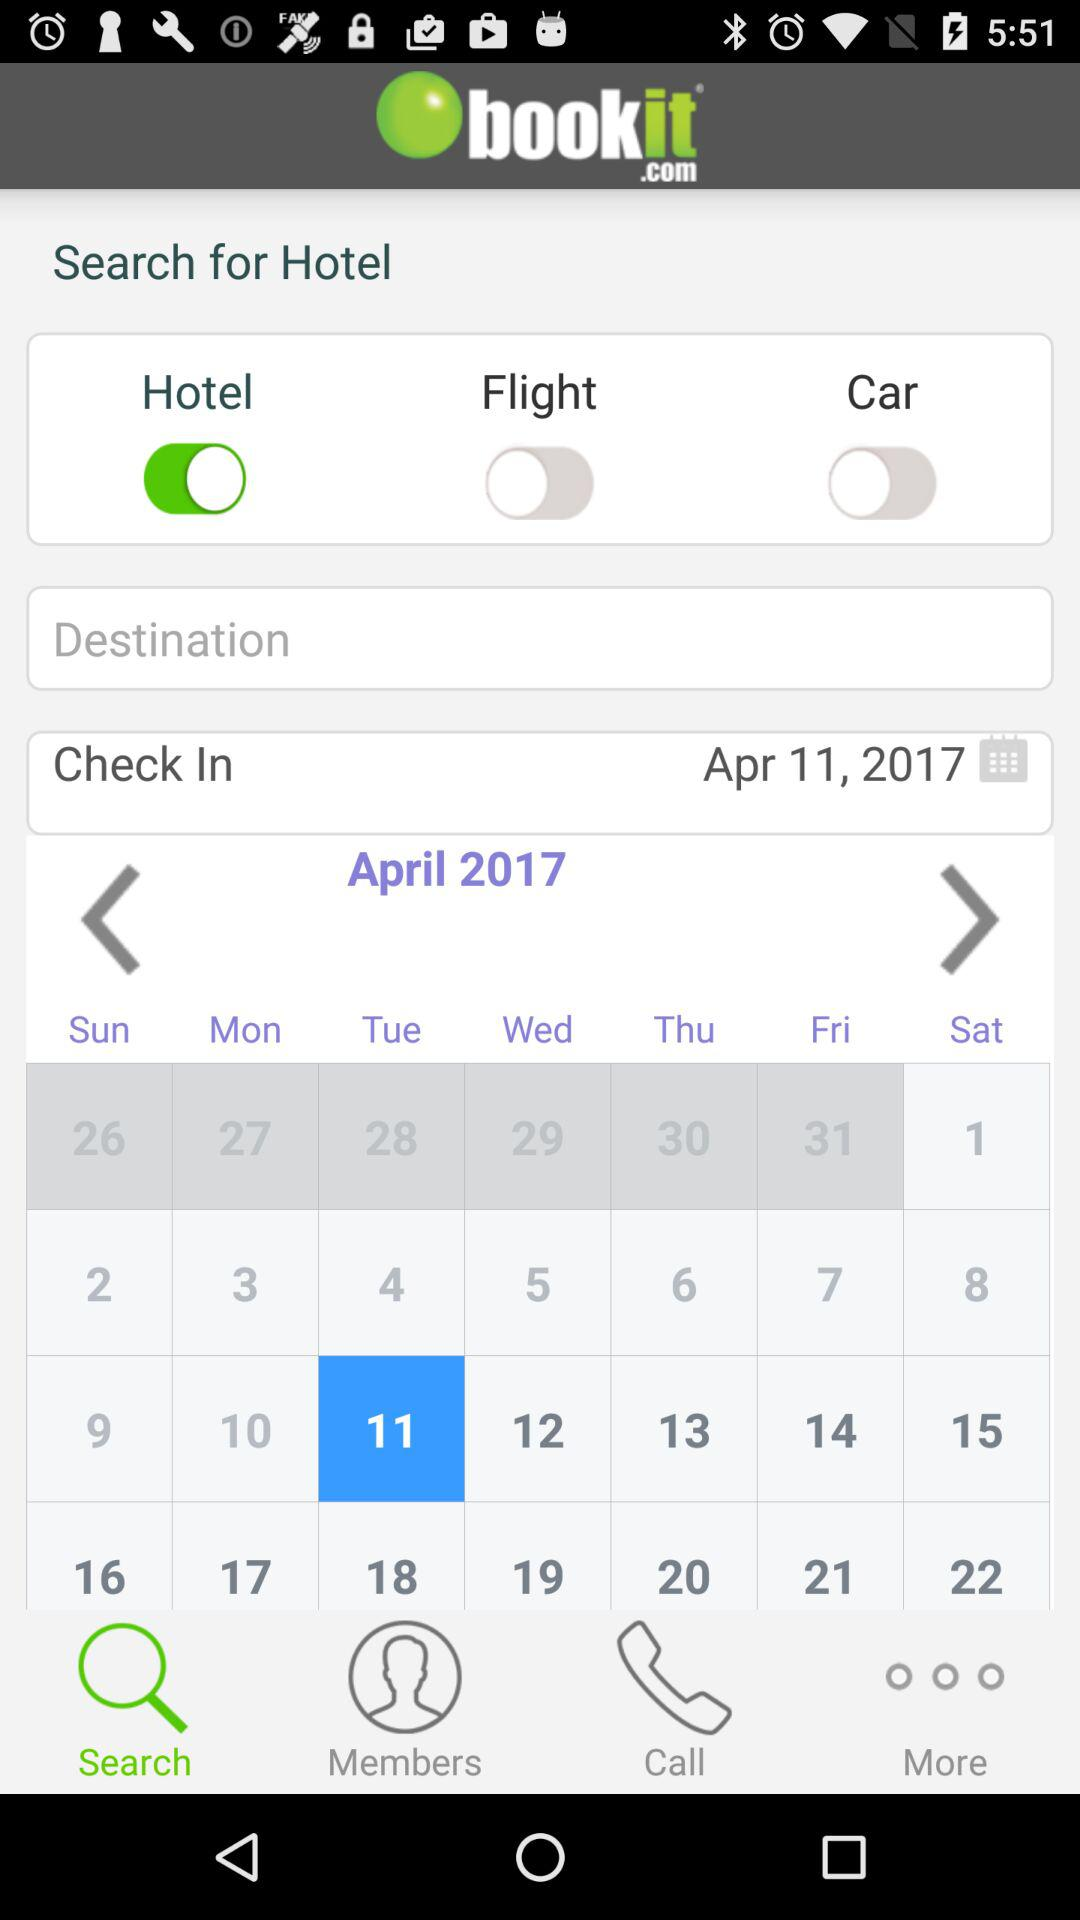What's the check-in date? The check-in date is April 11, 2017. 